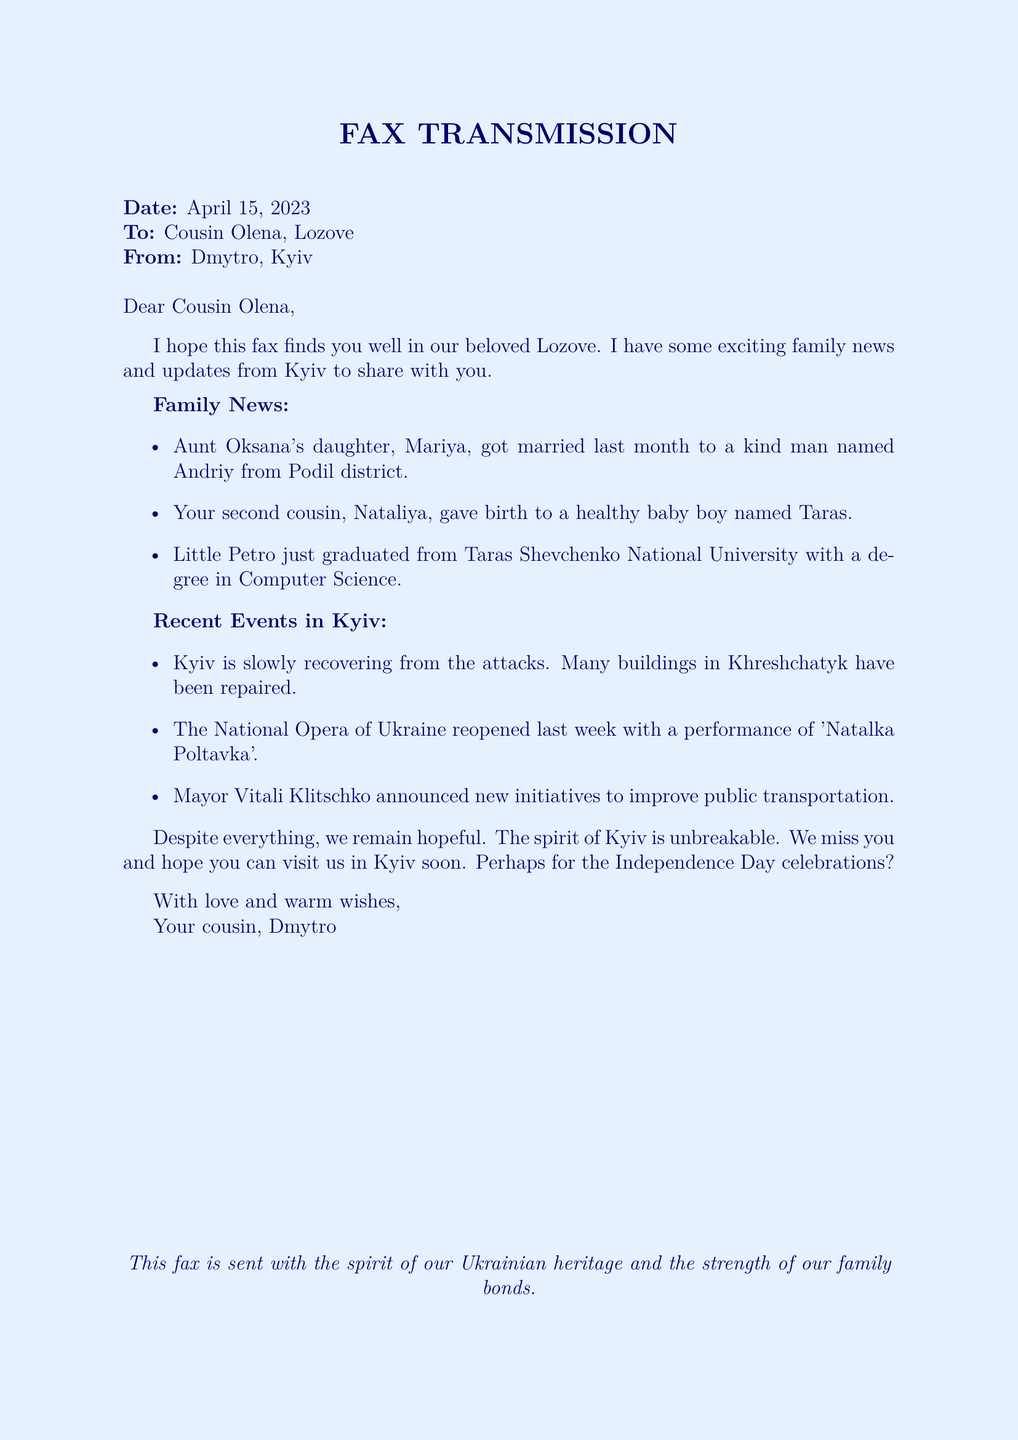What is the date of the fax? The date mentioned in the fax is specified near the top of the document.
Answer: April 15, 2023 Who is the sender of the fax? The sender's name is listed in the "From" section of the fax.
Answer: Dmytro Who got married last month? The person who got married is mentioned in the family news section.
Answer: Mariya What is the name of Aunt Oksana's daughter's husband? The name of Aunt Oksana's daughter's husband is indicated in the family news list.
Answer: Andriy What did little Petro graduate in? The area of study for little Petro is stated in the family news section.
Answer: Computer Science What initiative did Mayor Vitali Klitschko announce? The type of initiative is described in the recent events section of the fax.
Answer: Public transportation What event marked the reopening of the National Opera of Ukraine? The performance associated with the reopening is detailed in the 'Recent Events in Kyiv' section.
Answer: Natalka Poltavka What does Dmytro express towards Olena? The feelings expressed by Dmytro are contained in the closing lines of the letter.
Answer: Love and warm wishes What does Dmytro hope for regarding visits? Dmytro expresses a desire for a visit during a specific occasion.
Answer: Independence Day celebrations 